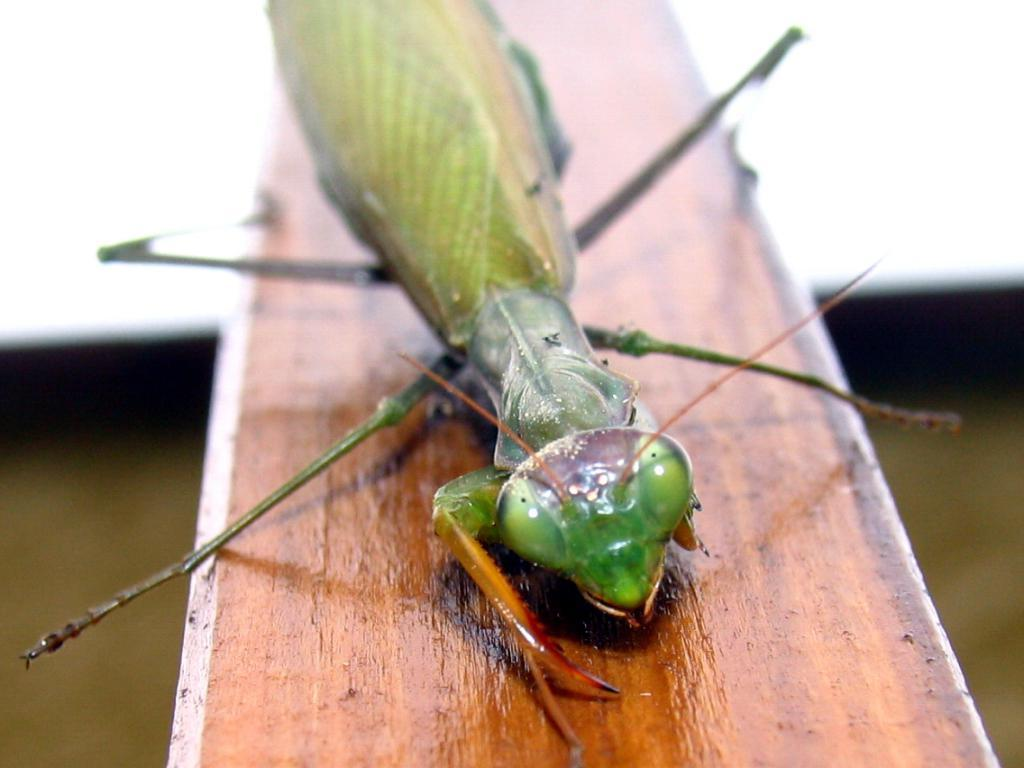What type of creature is present in the image? There is an insect in the image. What surface is the insect on? The insect is on a wooden surface. Can you describe the background of the image? The background of the image is blurry. What type of hair can be seen on the fowl in the image? There is no fowl or hair present in the image; it features an insect on a wooden surface with a blurry background. 